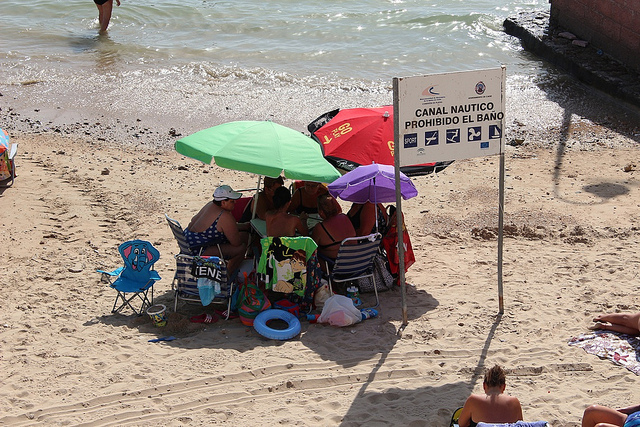Please transcribe the text in this image. CANAL NAUTICO PROHIBIDO EL BANO TENE GO 